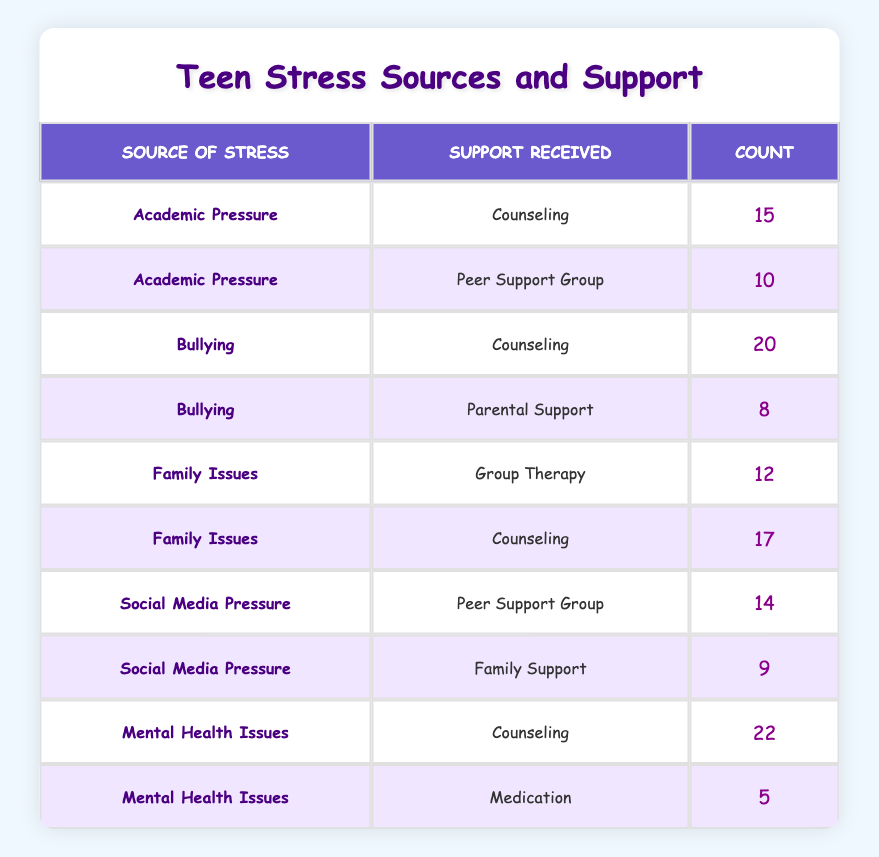What is the count of teenagers receiving counseling for mental health issues? In the table, we look for the row where the source of stress is "Mental Health Issues" and the support received is "Counseling." It shows a count of 22 teenagers.
Answer: 22 How many teenagers reported being stressed by family issues and received counseling? We find the row where the source is "Family Issues" and support is "Counseling." The table indicates that 17 teenagers received this support for family issues.
Answer: 17 What is the total count of teenagers who experienced bullying? To find this, we sum the counts for all rows where the source is "Bullying." The counts are 20 (counseling) and 8 (parental support), totaling 28.
Answer: 28 Did more teenagers report stress due to academic pressure or bullying? We need to compare the counts for "Academic Pressure" (15 + 10 = 25) and "Bullying" (20 + 8 = 28). Bullying has a higher total count, thus indicating more teenagers reported stress due to bullying.
Answer: Yes What is the average number of teenagers receiving peer support for "Social Media Pressure"? We identify the peer support count for "Social Media Pressure," which is 14. Since there is only this one entry for peer support, the average remains the same at 14.
Answer: 14 How many teenagers reported mental health issues but received medication as support? In the table, we find that 5 teenagers received medication for mental health issues as a source of stress.
Answer: 5 What is the difference in counts between teenagers receiving counseling for mental health issues and those receiving counseling for bullying? We find that counseling for mental health issues had a count of 22, while counseling for bullying had a count of 20. The difference is calculated as 22 - 20 = 2.
Answer: 2 Which type of support was least utilized among the listed sources of stress? We compare the counts of support received for each source of stress. The smallest count is 5 for "Medication" under "Mental Health Issues," indicating it is the least utilized support.
Answer: Medication How many teenagers reported receiving family support related to social media pressure? In the table, we see that 9 teenagers received family support specifically for social media pressure.
Answer: 9 